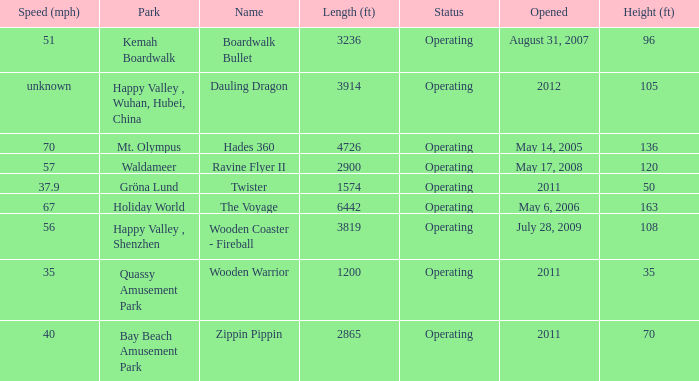How long is the rollar coaster on Kemah Boardwalk 3236.0. 